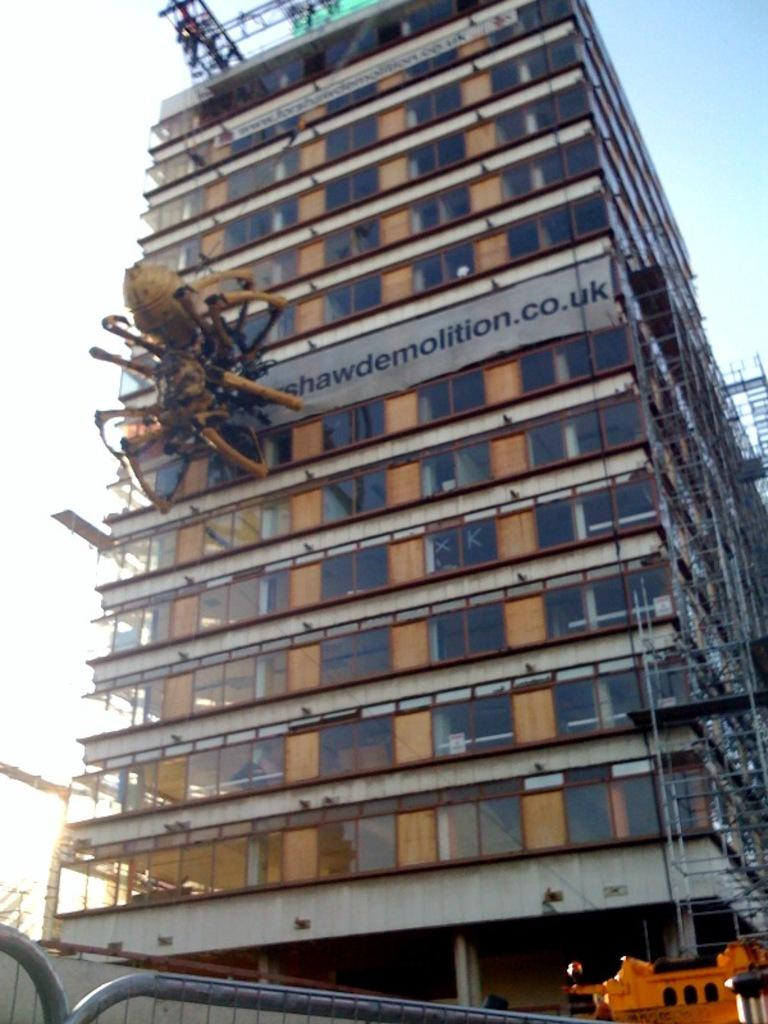What type of structure can be seen in the image? There is a building in the image. What is happening to the building? The building is undergoing a construction process. What equipment is present in the image? There is a crane in the image. What is used to restrict access in the image? There is a barricade in the image. What can be seen in the background of the image? The sky is visible in the image. What thoughts are the building having during the construction process? Buildings do not have thoughts, so this question cannot be answered. 